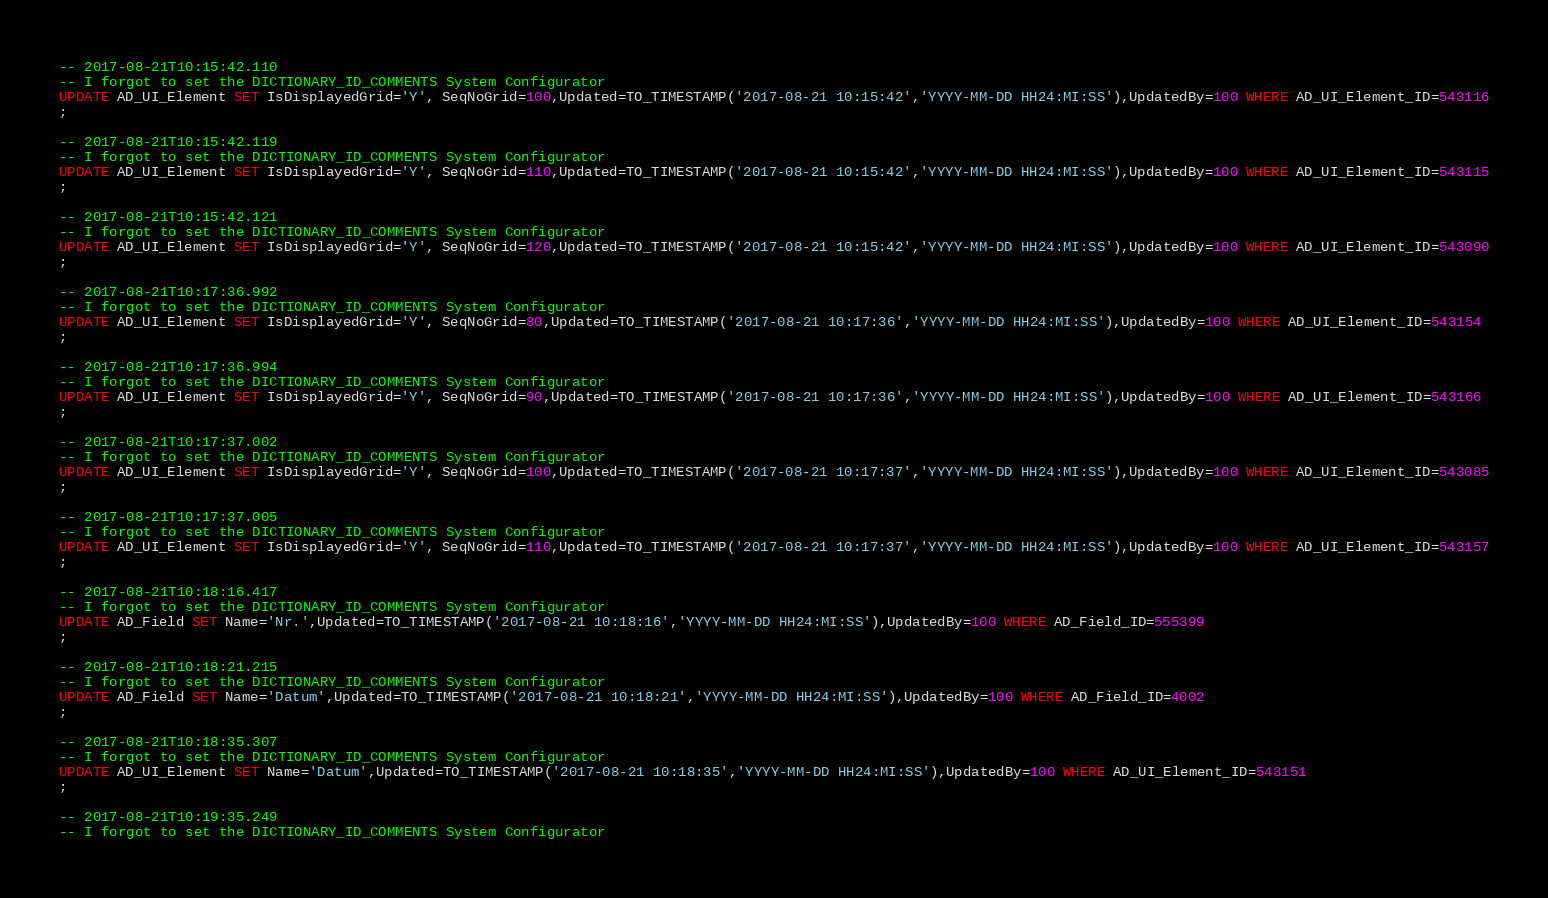<code> <loc_0><loc_0><loc_500><loc_500><_SQL_>-- 2017-08-21T10:15:42.110
-- I forgot to set the DICTIONARY_ID_COMMENTS System Configurator
UPDATE AD_UI_Element SET IsDisplayedGrid='Y', SeqNoGrid=100,Updated=TO_TIMESTAMP('2017-08-21 10:15:42','YYYY-MM-DD HH24:MI:SS'),UpdatedBy=100 WHERE AD_UI_Element_ID=543116
;

-- 2017-08-21T10:15:42.119
-- I forgot to set the DICTIONARY_ID_COMMENTS System Configurator
UPDATE AD_UI_Element SET IsDisplayedGrid='Y', SeqNoGrid=110,Updated=TO_TIMESTAMP('2017-08-21 10:15:42','YYYY-MM-DD HH24:MI:SS'),UpdatedBy=100 WHERE AD_UI_Element_ID=543115
;

-- 2017-08-21T10:15:42.121
-- I forgot to set the DICTIONARY_ID_COMMENTS System Configurator
UPDATE AD_UI_Element SET IsDisplayedGrid='Y', SeqNoGrid=120,Updated=TO_TIMESTAMP('2017-08-21 10:15:42','YYYY-MM-DD HH24:MI:SS'),UpdatedBy=100 WHERE AD_UI_Element_ID=543090
;

-- 2017-08-21T10:17:36.992
-- I forgot to set the DICTIONARY_ID_COMMENTS System Configurator
UPDATE AD_UI_Element SET IsDisplayedGrid='Y', SeqNoGrid=80,Updated=TO_TIMESTAMP('2017-08-21 10:17:36','YYYY-MM-DD HH24:MI:SS'),UpdatedBy=100 WHERE AD_UI_Element_ID=543154
;

-- 2017-08-21T10:17:36.994
-- I forgot to set the DICTIONARY_ID_COMMENTS System Configurator
UPDATE AD_UI_Element SET IsDisplayedGrid='Y', SeqNoGrid=90,Updated=TO_TIMESTAMP('2017-08-21 10:17:36','YYYY-MM-DD HH24:MI:SS'),UpdatedBy=100 WHERE AD_UI_Element_ID=543166
;

-- 2017-08-21T10:17:37.002
-- I forgot to set the DICTIONARY_ID_COMMENTS System Configurator
UPDATE AD_UI_Element SET IsDisplayedGrid='Y', SeqNoGrid=100,Updated=TO_TIMESTAMP('2017-08-21 10:17:37','YYYY-MM-DD HH24:MI:SS'),UpdatedBy=100 WHERE AD_UI_Element_ID=543085
;

-- 2017-08-21T10:17:37.005
-- I forgot to set the DICTIONARY_ID_COMMENTS System Configurator
UPDATE AD_UI_Element SET IsDisplayedGrid='Y', SeqNoGrid=110,Updated=TO_TIMESTAMP('2017-08-21 10:17:37','YYYY-MM-DD HH24:MI:SS'),UpdatedBy=100 WHERE AD_UI_Element_ID=543157
;

-- 2017-08-21T10:18:16.417
-- I forgot to set the DICTIONARY_ID_COMMENTS System Configurator
UPDATE AD_Field SET Name='Nr.',Updated=TO_TIMESTAMP('2017-08-21 10:18:16','YYYY-MM-DD HH24:MI:SS'),UpdatedBy=100 WHERE AD_Field_ID=555399
;

-- 2017-08-21T10:18:21.215
-- I forgot to set the DICTIONARY_ID_COMMENTS System Configurator
UPDATE AD_Field SET Name='Datum',Updated=TO_TIMESTAMP('2017-08-21 10:18:21','YYYY-MM-DD HH24:MI:SS'),UpdatedBy=100 WHERE AD_Field_ID=4002
;

-- 2017-08-21T10:18:35.307
-- I forgot to set the DICTIONARY_ID_COMMENTS System Configurator
UPDATE AD_UI_Element SET Name='Datum',Updated=TO_TIMESTAMP('2017-08-21 10:18:35','YYYY-MM-DD HH24:MI:SS'),UpdatedBy=100 WHERE AD_UI_Element_ID=543151
;

-- 2017-08-21T10:19:35.249
-- I forgot to set the DICTIONARY_ID_COMMENTS System Configurator</code> 